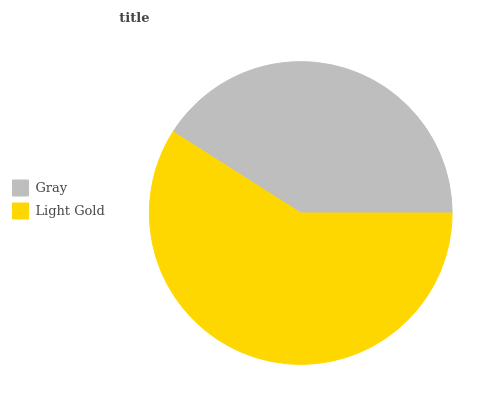Is Gray the minimum?
Answer yes or no. Yes. Is Light Gold the maximum?
Answer yes or no. Yes. Is Light Gold the minimum?
Answer yes or no. No. Is Light Gold greater than Gray?
Answer yes or no. Yes. Is Gray less than Light Gold?
Answer yes or no. Yes. Is Gray greater than Light Gold?
Answer yes or no. No. Is Light Gold less than Gray?
Answer yes or no. No. Is Light Gold the high median?
Answer yes or no. Yes. Is Gray the low median?
Answer yes or no. Yes. Is Gray the high median?
Answer yes or no. No. Is Light Gold the low median?
Answer yes or no. No. 